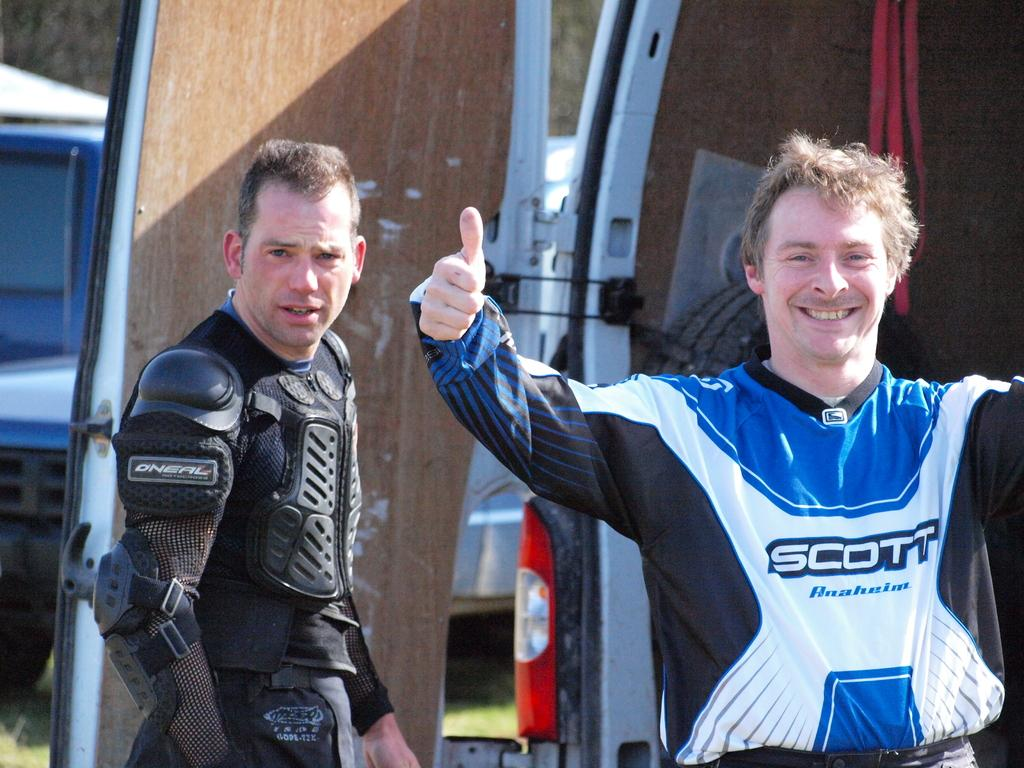<image>
Summarize the visual content of the image. Athlete with thumbs up with a jersey on with Scott acrossed the front. 